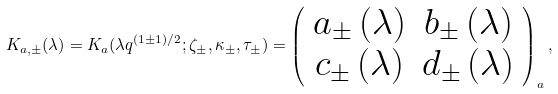Convert formula to latex. <formula><loc_0><loc_0><loc_500><loc_500>K _ { a , \pm } ( \lambda ) = K _ { a } ( \lambda q ^ { ( 1 \pm 1 ) / 2 } ; \zeta _ { \pm } , \kappa _ { \pm } , \tau _ { \pm } ) = \left ( \begin{array} { c c } a _ { \pm } \left ( \lambda \right ) & b _ { \pm } \left ( \lambda \right ) \\ c _ { \pm } \left ( \lambda \right ) & d _ { \pm } \left ( \lambda \right ) \end{array} \right ) _ { a } ,</formula> 